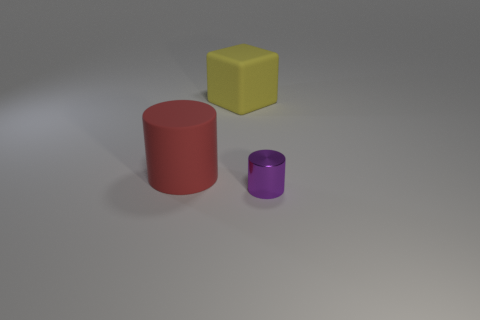There is a metal thing; is its color the same as the rubber object that is behind the big cylinder?
Offer a very short reply. No. What shape is the red matte thing?
Provide a succinct answer. Cylinder. Do the metallic cylinder and the rubber cylinder have the same color?
Give a very brief answer. No. How many things are cylinders to the left of the yellow object or tiny cylinders?
Offer a very short reply. 2. What is the size of the yellow block that is made of the same material as the red cylinder?
Provide a succinct answer. Large. Is the number of big red things behind the large yellow matte object greater than the number of yellow rubber cubes?
Ensure brevity in your answer.  No. Does the yellow object have the same shape as the rubber object to the left of the yellow rubber thing?
Your response must be concise. No. What number of small things are yellow rubber blocks or red matte cylinders?
Provide a succinct answer. 0. There is a rubber object that is behind the cylinder that is left of the tiny cylinder; what is its color?
Give a very brief answer. Yellow. Is the tiny purple cylinder made of the same material as the thing behind the red cylinder?
Provide a short and direct response. No. 